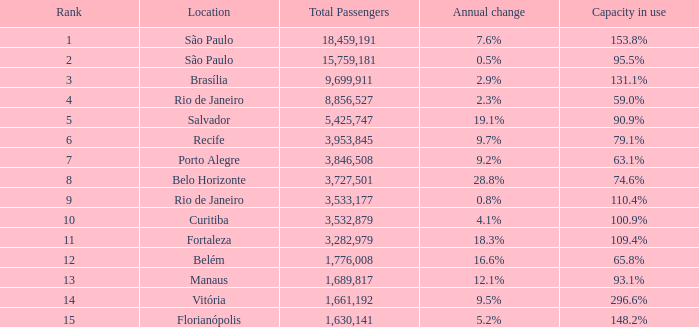What is the sum of Total Passengers when the annual change is 9.7% and the rank is less than 6? None. 